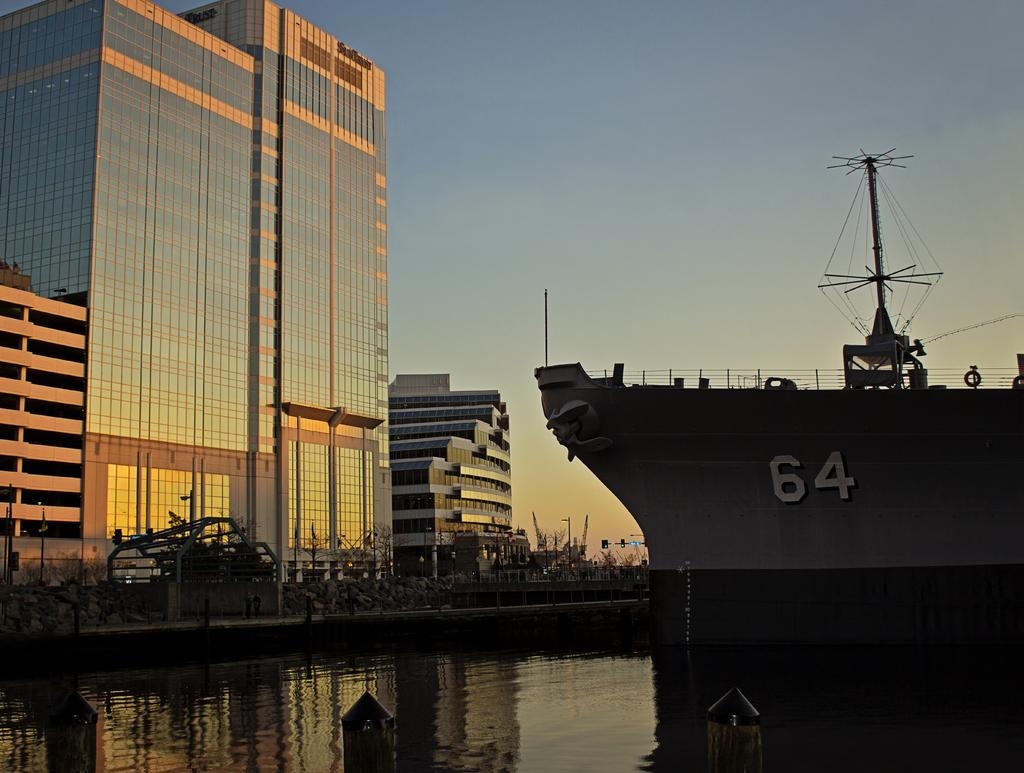What is the main subject of the image? There is a ship in the image. Where is the ship located? The ship is on the water. What structures can be seen on the ship? There is a fence and a pole on the ship. What is visible on the left side of the ship? There are buildings and other items on the left side of the ship. What can be seen in the sky in the image? The sky is visible in the image. Can you see the book that the ship is biting in the image? There is no book present in the image, and ships do not have the ability to bite. 